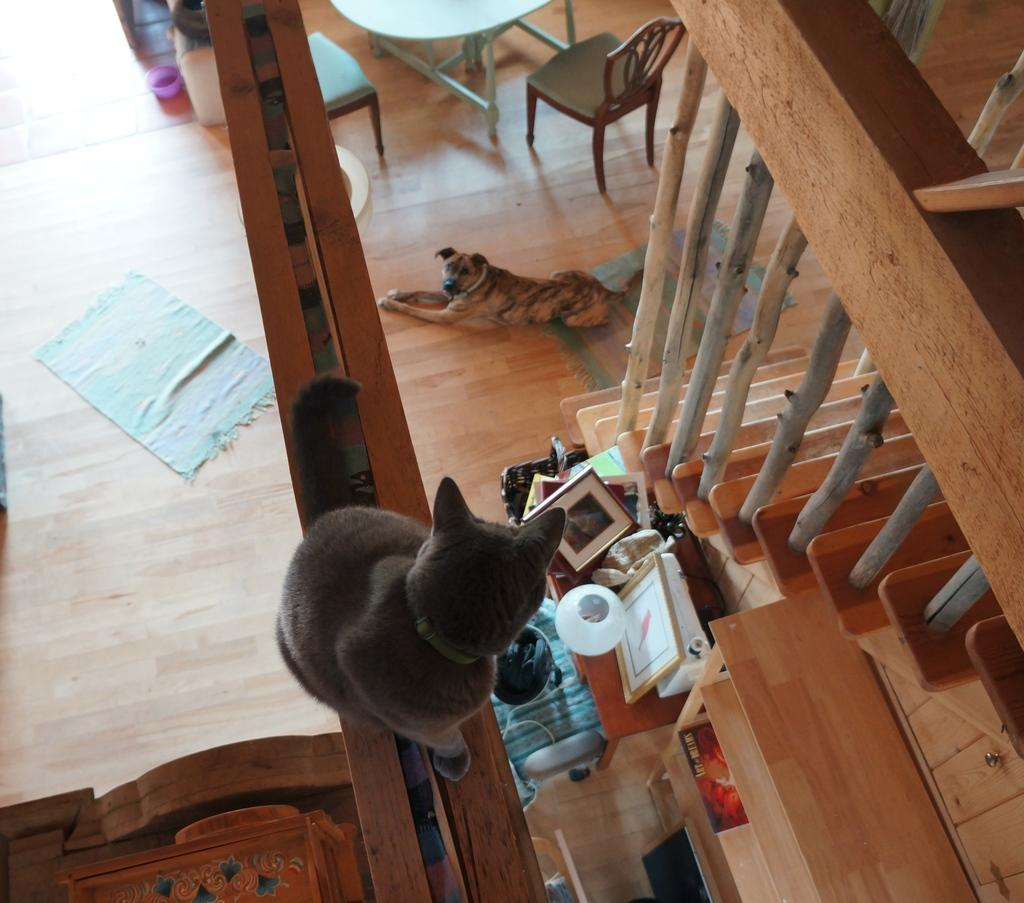What animals can be seen in the image? There is a cat and a dog in the image. What objects are on the table in the image? There are frames on the table in the image. What type of furniture is in the image? There is a chair in the image. What architectural feature is present in the image? There are stairs in the image. What shape is the collar of the cat in the image? There is no collar visible on the cat in the image. 